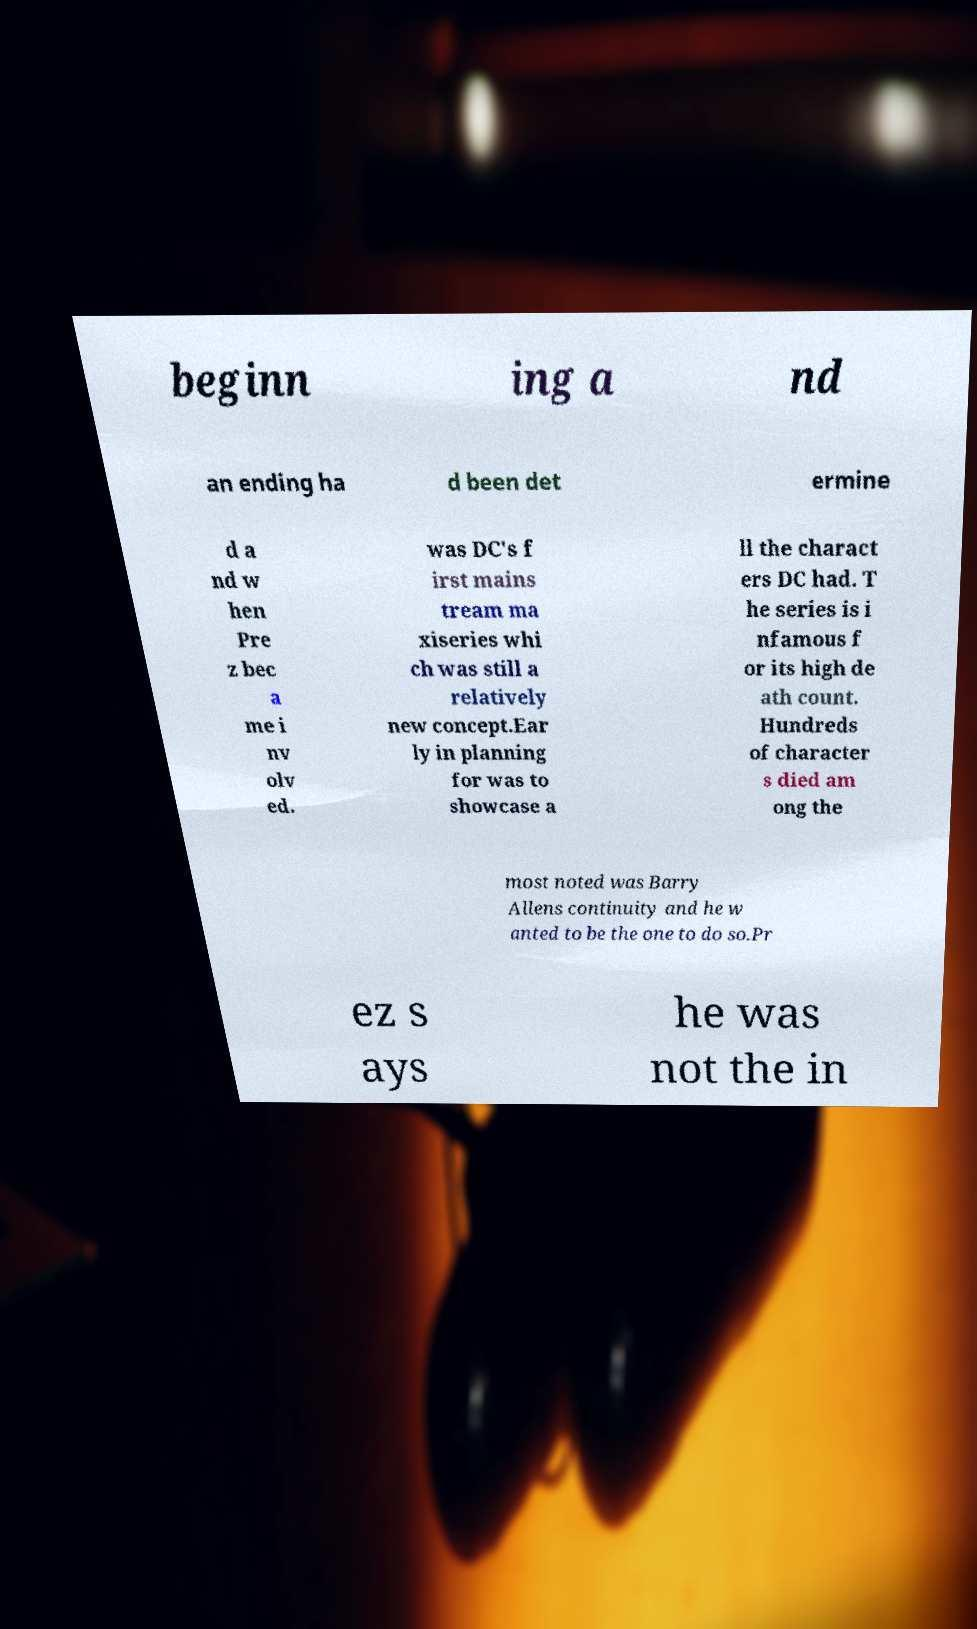Can you read and provide the text displayed in the image?This photo seems to have some interesting text. Can you extract and type it out for me? beginn ing a nd an ending ha d been det ermine d a nd w hen Pre z bec a me i nv olv ed. was DC's f irst mains tream ma xiseries whi ch was still a relatively new concept.Ear ly in planning for was to showcase a ll the charact ers DC had. T he series is i nfamous f or its high de ath count. Hundreds of character s died am ong the most noted was Barry Allens continuity and he w anted to be the one to do so.Pr ez s ays he was not the in 